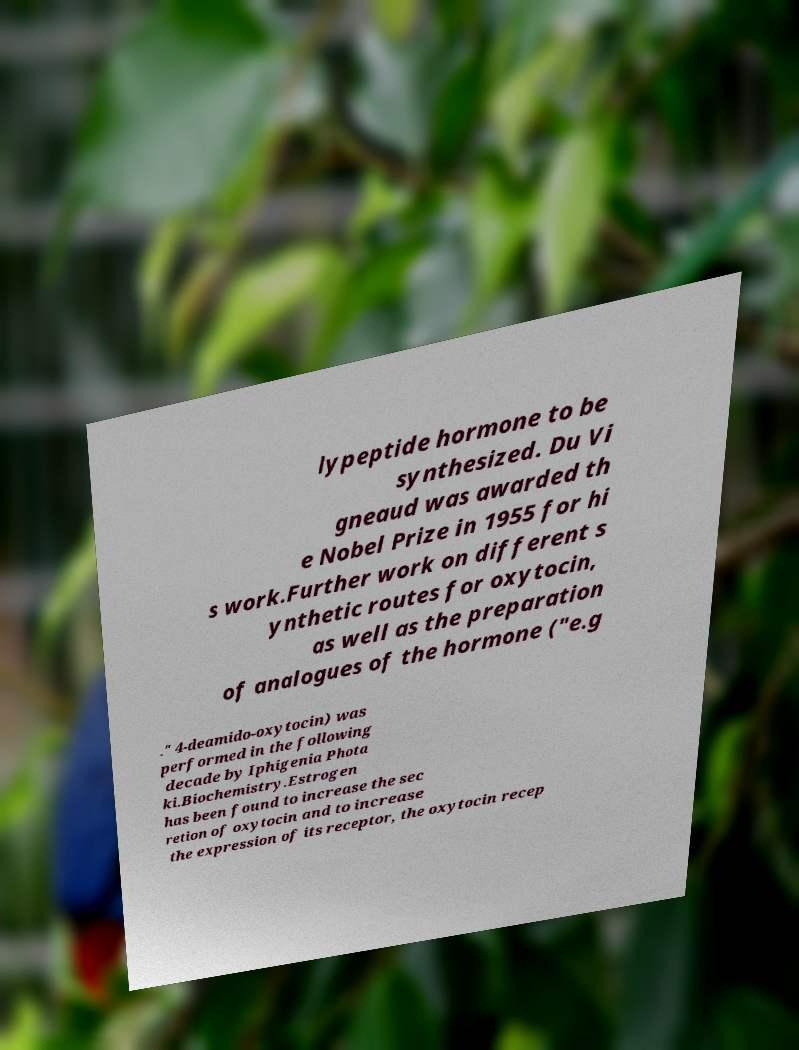Can you read and provide the text displayed in the image?This photo seems to have some interesting text. Can you extract and type it out for me? lypeptide hormone to be synthesized. Du Vi gneaud was awarded th e Nobel Prize in 1955 for hi s work.Further work on different s ynthetic routes for oxytocin, as well as the preparation of analogues of the hormone ("e.g ." 4-deamido-oxytocin) was performed in the following decade by Iphigenia Phota ki.Biochemistry.Estrogen has been found to increase the sec retion of oxytocin and to increase the expression of its receptor, the oxytocin recep 